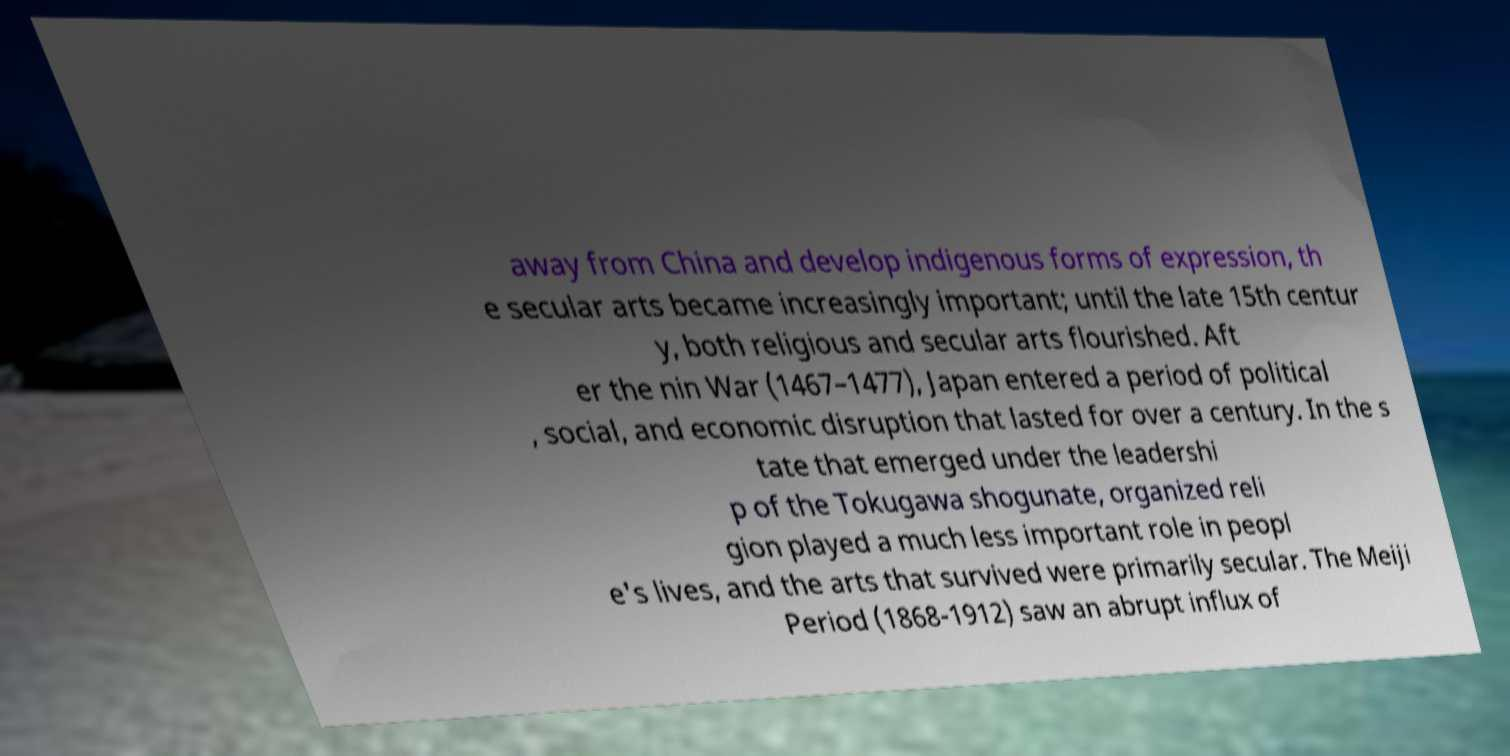Can you accurately transcribe the text from the provided image for me? away from China and develop indigenous forms of expression, th e secular arts became increasingly important; until the late 15th centur y, both religious and secular arts flourished. Aft er the nin War (1467–1477), Japan entered a period of political , social, and economic disruption that lasted for over a century. In the s tate that emerged under the leadershi p of the Tokugawa shogunate, organized reli gion played a much less important role in peopl e's lives, and the arts that survived were primarily secular. The Meiji Period (1868-1912) saw an abrupt influx of 